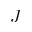<formula> <loc_0><loc_0><loc_500><loc_500>J</formula> 